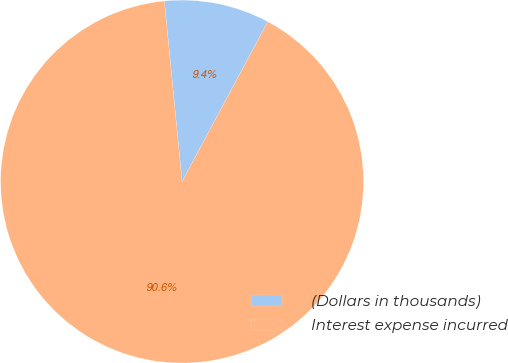<chart> <loc_0><loc_0><loc_500><loc_500><pie_chart><fcel>(Dollars in thousands)<fcel>Interest expense incurred<nl><fcel>9.39%<fcel>90.61%<nl></chart> 